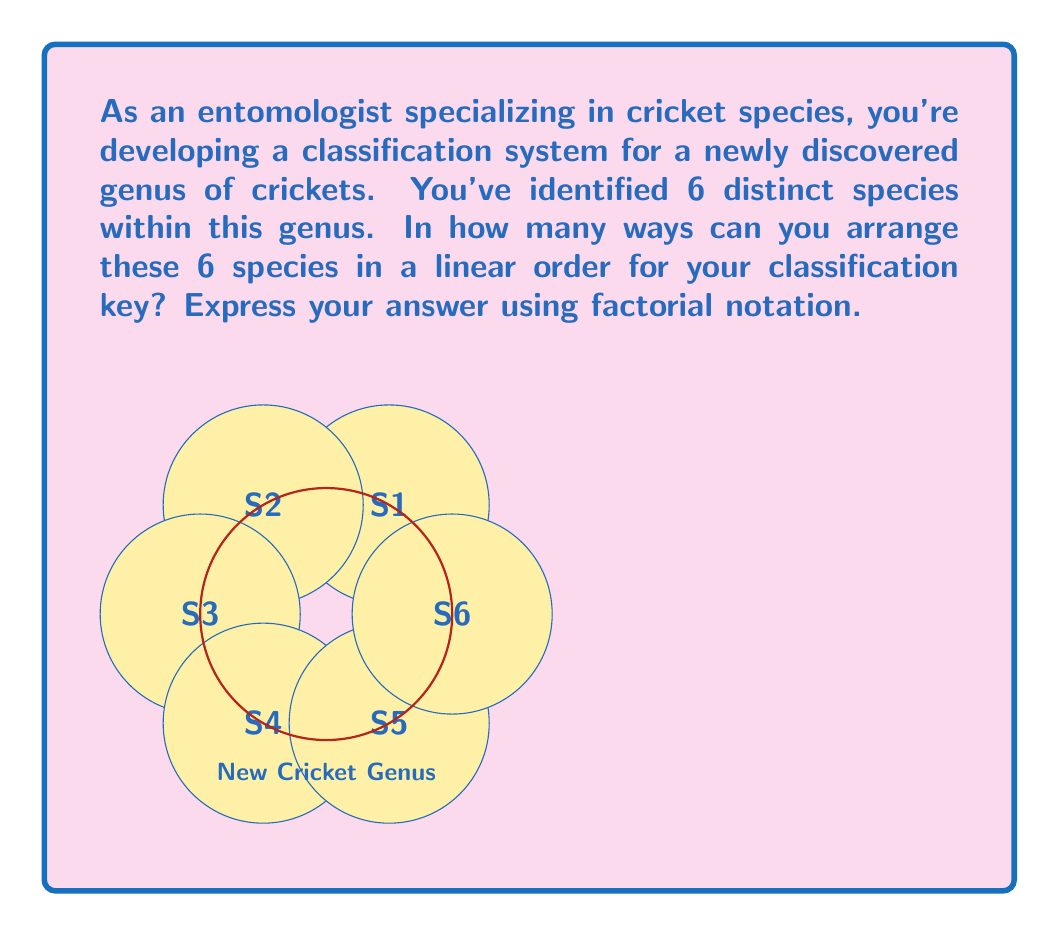Can you answer this question? Let's approach this step-by-step:

1) In this problem, we are essentially dealing with permutations. We need to find out in how many ways we can arrange 6 distinct objects (the 6 cricket species) in a linear order.

2) This is a classic application of the permutation concept in Abstract Algebra. The number of permutations of n distinct objects is given by $n!$ (n factorial).

3) In our case, $n = 6$ (as we have 6 distinct species).

4) Therefore, the number of ways to arrange these 6 species is $6!$.

5) To understand why this works, let's break it down:
   - For the first position, we have 6 choices
   - For the second position, we have 5 remaining choices
   - For the third position, we have 4 remaining choices
   - And so on...

6) Mathematically, this gives us:

   $6 \times 5 \times 4 \times 3 \times 2 \times 1 = 6!$

7) The order of this permutation group is thus $6!$.
Answer: $6!$ 